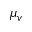Convert formula to latex. <formula><loc_0><loc_0><loc_500><loc_500>\mu _ { v }</formula> 